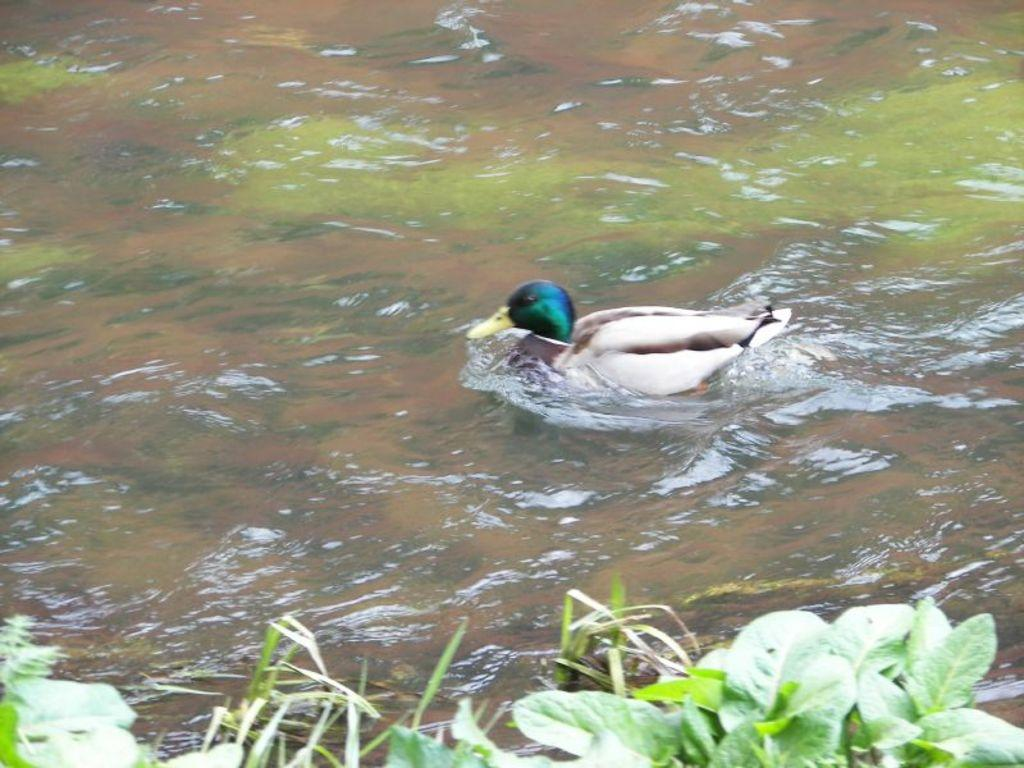What type of animal can be seen in the image? There is a bird in the image. Where is the bird located? The bird is on the water. In which direction is the bird facing? The bird is facing towards the left side. What can be seen at the bottom of the image? There are plants visible at the bottom of the image. How far away is the chicken from the bird in the image? There is no chicken present in the image, so it is not possible to determine the distance between a chicken and the bird. 